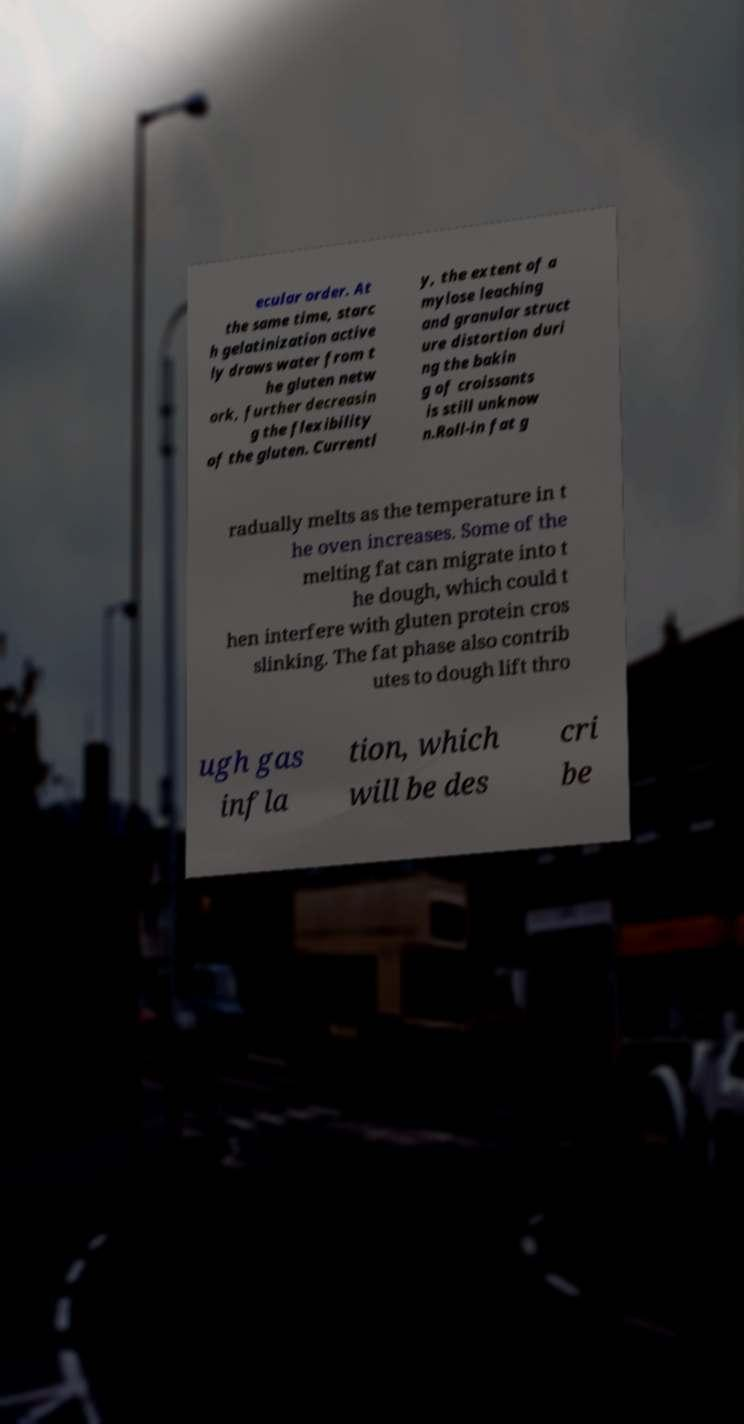There's text embedded in this image that I need extracted. Can you transcribe it verbatim? ecular order. At the same time, starc h gelatinization active ly draws water from t he gluten netw ork, further decreasin g the flexibility of the gluten. Currentl y, the extent of a mylose leaching and granular struct ure distortion duri ng the bakin g of croissants is still unknow n.Roll-in fat g radually melts as the temperature in t he oven increases. Some of the melting fat can migrate into t he dough, which could t hen interfere with gluten protein cros slinking. The fat phase also contrib utes to dough lift thro ugh gas infla tion, which will be des cri be 